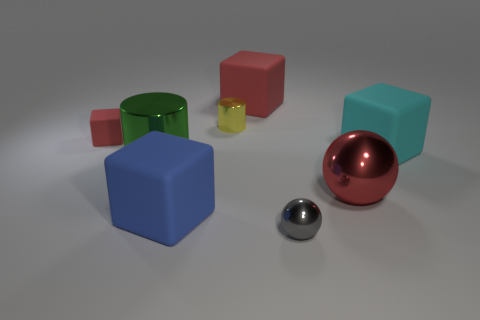Subtract all gray blocks. Subtract all yellow balls. How many blocks are left? 4 Add 1 small gray things. How many objects exist? 9 Subtract all balls. How many objects are left? 6 Add 2 yellow metal things. How many yellow metal things are left? 3 Add 5 blue metal balls. How many blue metal balls exist? 5 Subtract 1 cyan cubes. How many objects are left? 7 Subtract all red rubber things. Subtract all tiny cubes. How many objects are left? 5 